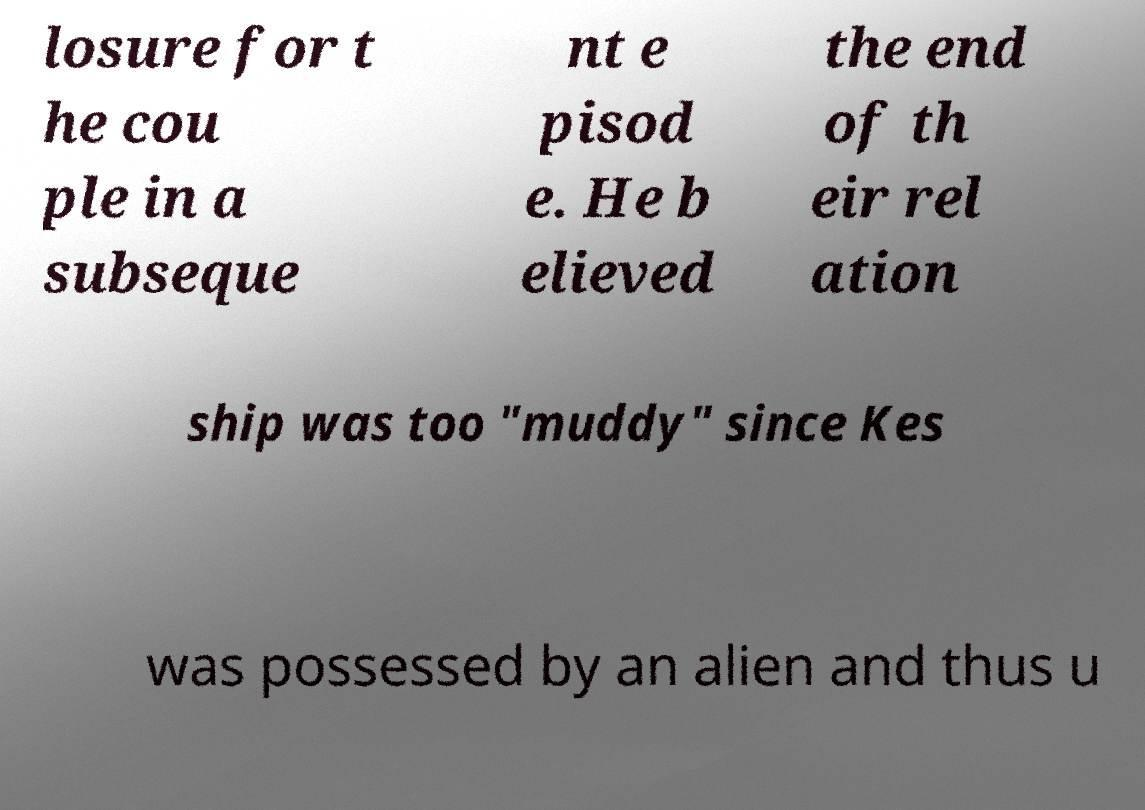Can you accurately transcribe the text from the provided image for me? losure for t he cou ple in a subseque nt e pisod e. He b elieved the end of th eir rel ation ship was too "muddy" since Kes was possessed by an alien and thus u 